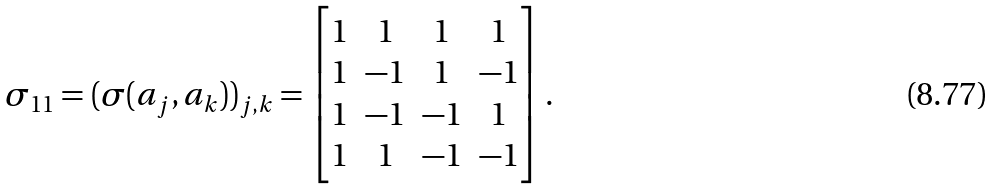<formula> <loc_0><loc_0><loc_500><loc_500>\sigma _ { 1 1 } = ( \sigma ( a _ { j } , a _ { k } ) ) _ { j , k } = \begin{bmatrix} 1 & 1 & 1 & 1 \\ 1 & - 1 & 1 & - 1 \\ 1 & - 1 & - 1 & 1 \\ 1 & 1 & - 1 & - 1 \end{bmatrix} .</formula> 